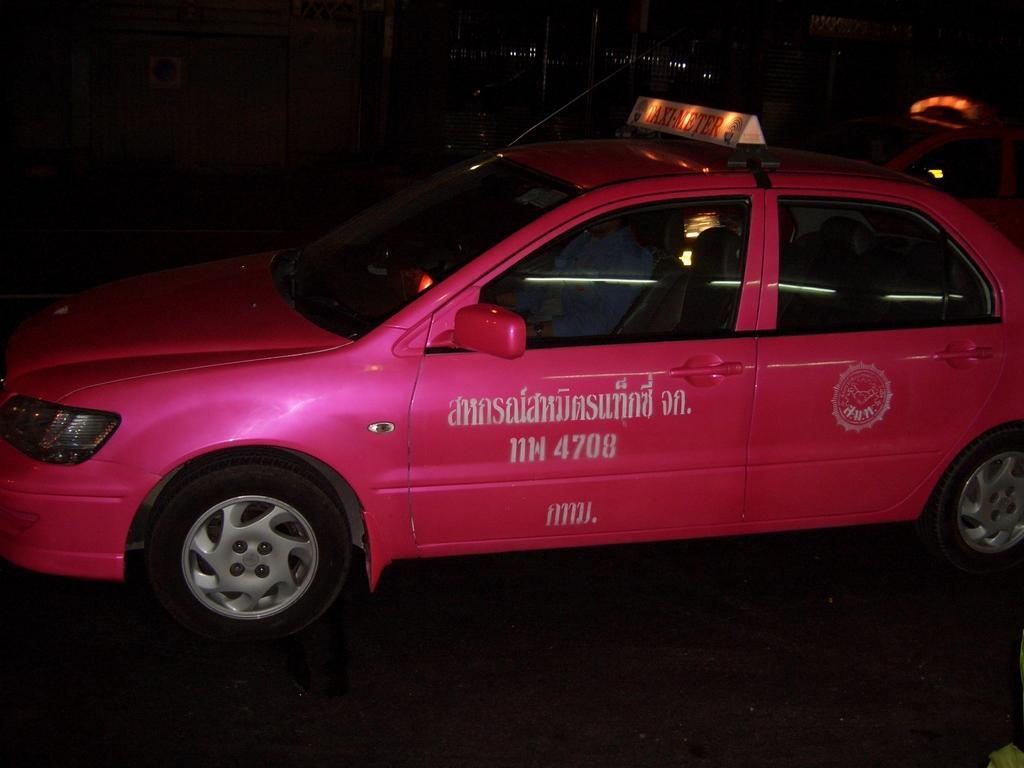Describe this image in one or two sentences. In this image we can see a person sitting inside a vehicle with a signboard and some text is placed on the ground. In the background, we can see a vehicle and some lights. 